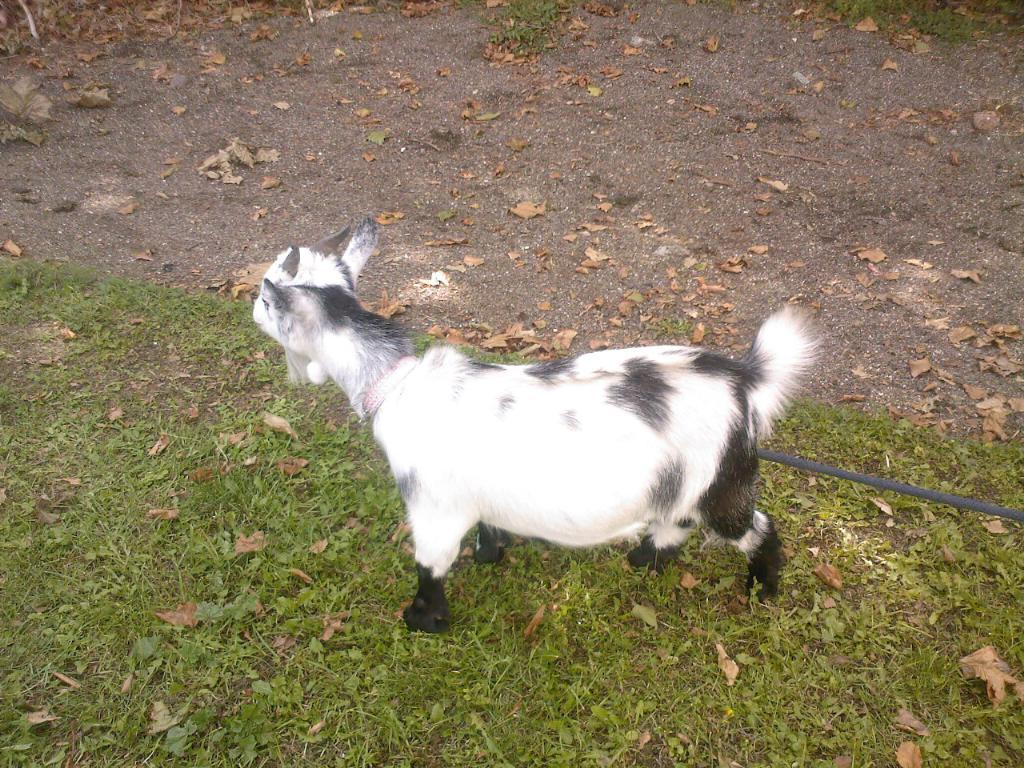What animal is present in the image? There is a goat in the image. How is the goat secured in the image? The goat is tied with a rope. What type of vegetation can be seen at the bottom of the image? There is grass visible at the bottom of the image. What type of foliage can be seen at the top of the image? There are dry leaves at the top of the image. What type of bean is growing on the goat's back in the image? There are no beans present in the image, and the goat's back is not shown. 